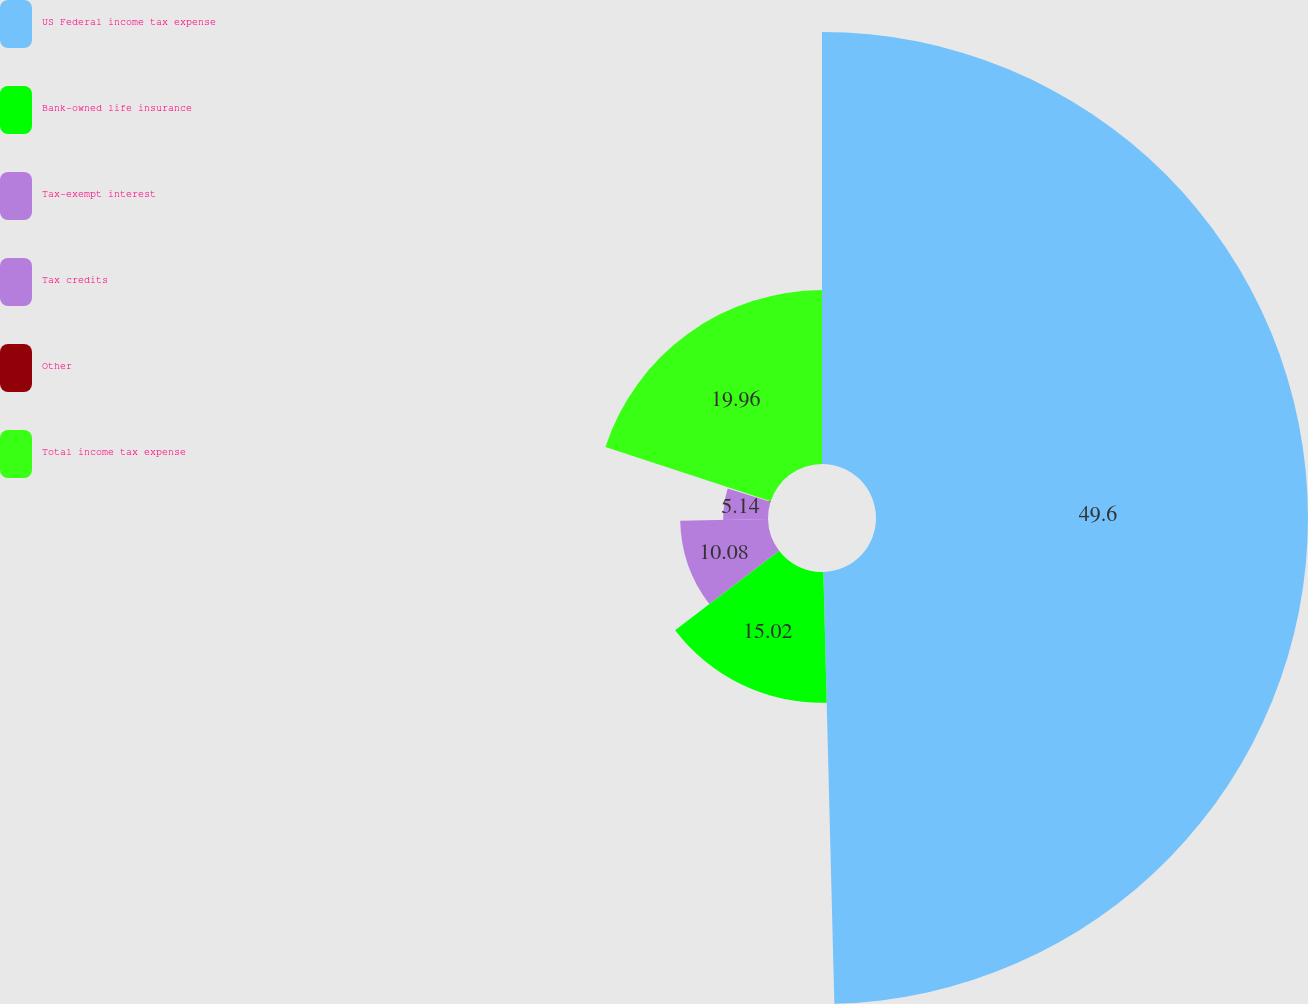Convert chart to OTSL. <chart><loc_0><loc_0><loc_500><loc_500><pie_chart><fcel>US Federal income tax expense<fcel>Bank-owned life insurance<fcel>Tax-exempt interest<fcel>Tax credits<fcel>Other<fcel>Total income tax expense<nl><fcel>49.59%<fcel>15.02%<fcel>10.08%<fcel>5.14%<fcel>0.2%<fcel>19.96%<nl></chart> 